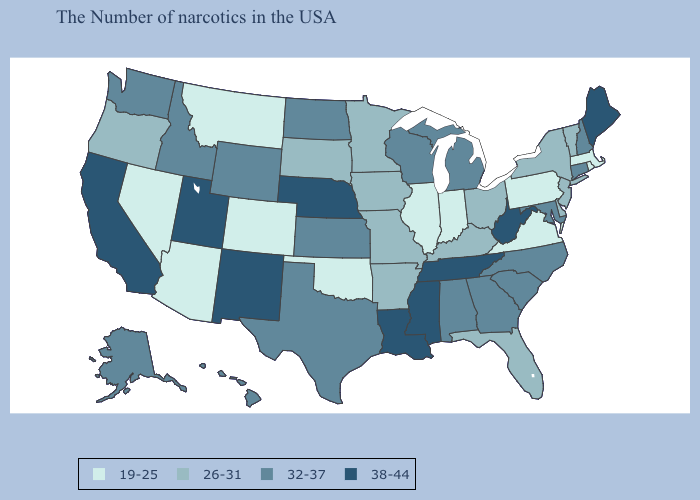Does Indiana have the highest value in the MidWest?
Give a very brief answer. No. Among the states that border Nevada , does Arizona have the lowest value?
Keep it brief. Yes. Among the states that border Montana , does North Dakota have the lowest value?
Give a very brief answer. No. Does Pennsylvania have the highest value in the Northeast?
Short answer required. No. Does Idaho have a lower value than Mississippi?
Concise answer only. Yes. What is the value of Iowa?
Quick response, please. 26-31. What is the value of Vermont?
Keep it brief. 26-31. Among the states that border Nevada , does Utah have the highest value?
Keep it brief. Yes. Name the states that have a value in the range 38-44?
Answer briefly. Maine, West Virginia, Tennessee, Mississippi, Louisiana, Nebraska, New Mexico, Utah, California. What is the highest value in the USA?
Give a very brief answer. 38-44. Name the states that have a value in the range 38-44?
Be succinct. Maine, West Virginia, Tennessee, Mississippi, Louisiana, Nebraska, New Mexico, Utah, California. Which states have the highest value in the USA?
Answer briefly. Maine, West Virginia, Tennessee, Mississippi, Louisiana, Nebraska, New Mexico, Utah, California. What is the value of Tennessee?
Be succinct. 38-44. Name the states that have a value in the range 19-25?
Concise answer only. Massachusetts, Rhode Island, Pennsylvania, Virginia, Indiana, Illinois, Oklahoma, Colorado, Montana, Arizona, Nevada. 